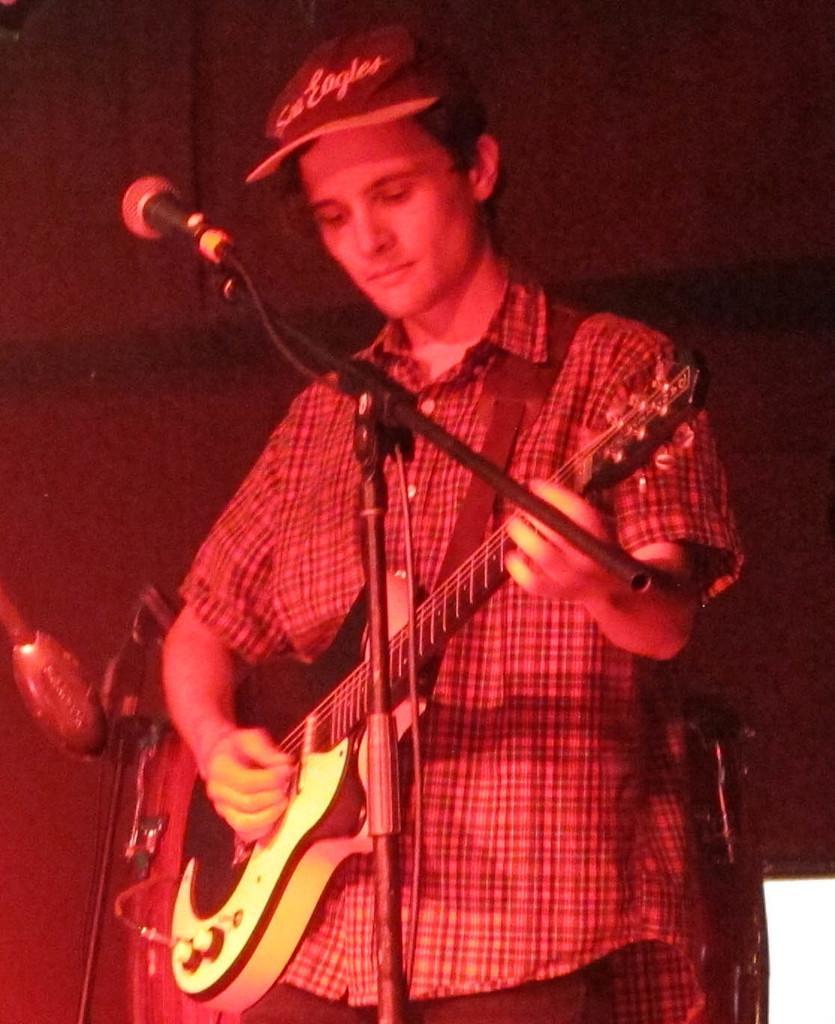Can you describe this image briefly? In this picture I can see there is a person standing and he is wearing a cap, playing a guitar and there is a microphone at left side, there is a wall in the backdrop. 